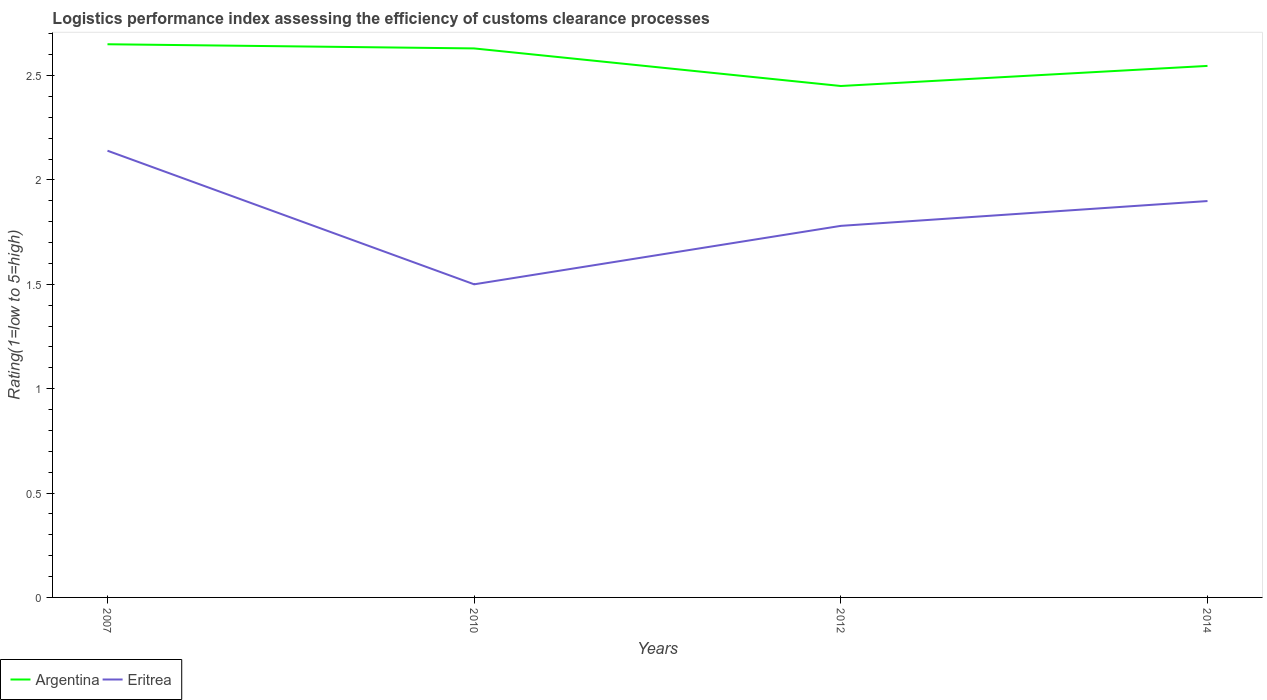Does the line corresponding to Argentina intersect with the line corresponding to Eritrea?
Your answer should be compact. No. Across all years, what is the maximum Logistic performance index in Argentina?
Your answer should be very brief. 2.45. What is the total Logistic performance index in Argentina in the graph?
Ensure brevity in your answer.  0.2. What is the difference between the highest and the second highest Logistic performance index in Argentina?
Offer a terse response. 0.2. What is the difference between the highest and the lowest Logistic performance index in Argentina?
Offer a terse response. 2. How many lines are there?
Keep it short and to the point. 2. Are the values on the major ticks of Y-axis written in scientific E-notation?
Offer a terse response. No. Does the graph contain any zero values?
Offer a very short reply. No. Does the graph contain grids?
Keep it short and to the point. No. How are the legend labels stacked?
Give a very brief answer. Horizontal. What is the title of the graph?
Ensure brevity in your answer.  Logistics performance index assessing the efficiency of customs clearance processes. Does "Netherlands" appear as one of the legend labels in the graph?
Your response must be concise. No. What is the label or title of the X-axis?
Provide a succinct answer. Years. What is the label or title of the Y-axis?
Make the answer very short. Rating(1=low to 5=high). What is the Rating(1=low to 5=high) of Argentina in 2007?
Your answer should be compact. 2.65. What is the Rating(1=low to 5=high) in Eritrea in 2007?
Give a very brief answer. 2.14. What is the Rating(1=low to 5=high) in Argentina in 2010?
Make the answer very short. 2.63. What is the Rating(1=low to 5=high) in Argentina in 2012?
Ensure brevity in your answer.  2.45. What is the Rating(1=low to 5=high) in Eritrea in 2012?
Provide a short and direct response. 1.78. What is the Rating(1=low to 5=high) in Argentina in 2014?
Keep it short and to the point. 2.55. What is the Rating(1=low to 5=high) of Eritrea in 2014?
Offer a very short reply. 1.9. Across all years, what is the maximum Rating(1=low to 5=high) in Argentina?
Offer a very short reply. 2.65. Across all years, what is the maximum Rating(1=low to 5=high) in Eritrea?
Your answer should be compact. 2.14. Across all years, what is the minimum Rating(1=low to 5=high) in Argentina?
Ensure brevity in your answer.  2.45. What is the total Rating(1=low to 5=high) in Argentina in the graph?
Your answer should be very brief. 10.28. What is the total Rating(1=low to 5=high) of Eritrea in the graph?
Provide a succinct answer. 7.32. What is the difference between the Rating(1=low to 5=high) in Eritrea in 2007 and that in 2010?
Your answer should be very brief. 0.64. What is the difference between the Rating(1=low to 5=high) of Eritrea in 2007 and that in 2012?
Provide a succinct answer. 0.36. What is the difference between the Rating(1=low to 5=high) of Argentina in 2007 and that in 2014?
Your answer should be compact. 0.1. What is the difference between the Rating(1=low to 5=high) of Eritrea in 2007 and that in 2014?
Ensure brevity in your answer.  0.24. What is the difference between the Rating(1=low to 5=high) in Argentina in 2010 and that in 2012?
Offer a terse response. 0.18. What is the difference between the Rating(1=low to 5=high) of Eritrea in 2010 and that in 2012?
Make the answer very short. -0.28. What is the difference between the Rating(1=low to 5=high) of Argentina in 2010 and that in 2014?
Your response must be concise. 0.08. What is the difference between the Rating(1=low to 5=high) of Eritrea in 2010 and that in 2014?
Your answer should be compact. -0.4. What is the difference between the Rating(1=low to 5=high) in Argentina in 2012 and that in 2014?
Ensure brevity in your answer.  -0.1. What is the difference between the Rating(1=low to 5=high) of Eritrea in 2012 and that in 2014?
Your answer should be very brief. -0.12. What is the difference between the Rating(1=low to 5=high) in Argentina in 2007 and the Rating(1=low to 5=high) in Eritrea in 2010?
Ensure brevity in your answer.  1.15. What is the difference between the Rating(1=low to 5=high) in Argentina in 2007 and the Rating(1=low to 5=high) in Eritrea in 2012?
Provide a succinct answer. 0.87. What is the difference between the Rating(1=low to 5=high) of Argentina in 2007 and the Rating(1=low to 5=high) of Eritrea in 2014?
Make the answer very short. 0.75. What is the difference between the Rating(1=low to 5=high) of Argentina in 2010 and the Rating(1=low to 5=high) of Eritrea in 2012?
Your answer should be very brief. 0.85. What is the difference between the Rating(1=low to 5=high) in Argentina in 2010 and the Rating(1=low to 5=high) in Eritrea in 2014?
Offer a very short reply. 0.73. What is the difference between the Rating(1=low to 5=high) in Argentina in 2012 and the Rating(1=low to 5=high) in Eritrea in 2014?
Keep it short and to the point. 0.55. What is the average Rating(1=low to 5=high) in Argentina per year?
Your answer should be compact. 2.57. What is the average Rating(1=low to 5=high) in Eritrea per year?
Make the answer very short. 1.83. In the year 2007, what is the difference between the Rating(1=low to 5=high) of Argentina and Rating(1=low to 5=high) of Eritrea?
Offer a very short reply. 0.51. In the year 2010, what is the difference between the Rating(1=low to 5=high) of Argentina and Rating(1=low to 5=high) of Eritrea?
Provide a succinct answer. 1.13. In the year 2012, what is the difference between the Rating(1=low to 5=high) in Argentina and Rating(1=low to 5=high) in Eritrea?
Provide a succinct answer. 0.67. In the year 2014, what is the difference between the Rating(1=low to 5=high) in Argentina and Rating(1=low to 5=high) in Eritrea?
Offer a terse response. 0.65. What is the ratio of the Rating(1=low to 5=high) in Argentina in 2007 to that in 2010?
Make the answer very short. 1.01. What is the ratio of the Rating(1=low to 5=high) in Eritrea in 2007 to that in 2010?
Your answer should be very brief. 1.43. What is the ratio of the Rating(1=low to 5=high) of Argentina in 2007 to that in 2012?
Give a very brief answer. 1.08. What is the ratio of the Rating(1=low to 5=high) of Eritrea in 2007 to that in 2012?
Provide a short and direct response. 1.2. What is the ratio of the Rating(1=low to 5=high) of Argentina in 2007 to that in 2014?
Provide a succinct answer. 1.04. What is the ratio of the Rating(1=low to 5=high) of Eritrea in 2007 to that in 2014?
Your answer should be very brief. 1.13. What is the ratio of the Rating(1=low to 5=high) of Argentina in 2010 to that in 2012?
Ensure brevity in your answer.  1.07. What is the ratio of the Rating(1=low to 5=high) of Eritrea in 2010 to that in 2012?
Offer a very short reply. 0.84. What is the ratio of the Rating(1=low to 5=high) of Argentina in 2010 to that in 2014?
Your answer should be compact. 1.03. What is the ratio of the Rating(1=low to 5=high) of Eritrea in 2010 to that in 2014?
Your answer should be compact. 0.79. What is the ratio of the Rating(1=low to 5=high) in Argentina in 2012 to that in 2014?
Provide a succinct answer. 0.96. What is the ratio of the Rating(1=low to 5=high) of Eritrea in 2012 to that in 2014?
Ensure brevity in your answer.  0.94. What is the difference between the highest and the second highest Rating(1=low to 5=high) in Argentina?
Your answer should be very brief. 0.02. What is the difference between the highest and the second highest Rating(1=low to 5=high) in Eritrea?
Offer a terse response. 0.24. What is the difference between the highest and the lowest Rating(1=low to 5=high) of Argentina?
Ensure brevity in your answer.  0.2. What is the difference between the highest and the lowest Rating(1=low to 5=high) in Eritrea?
Provide a short and direct response. 0.64. 